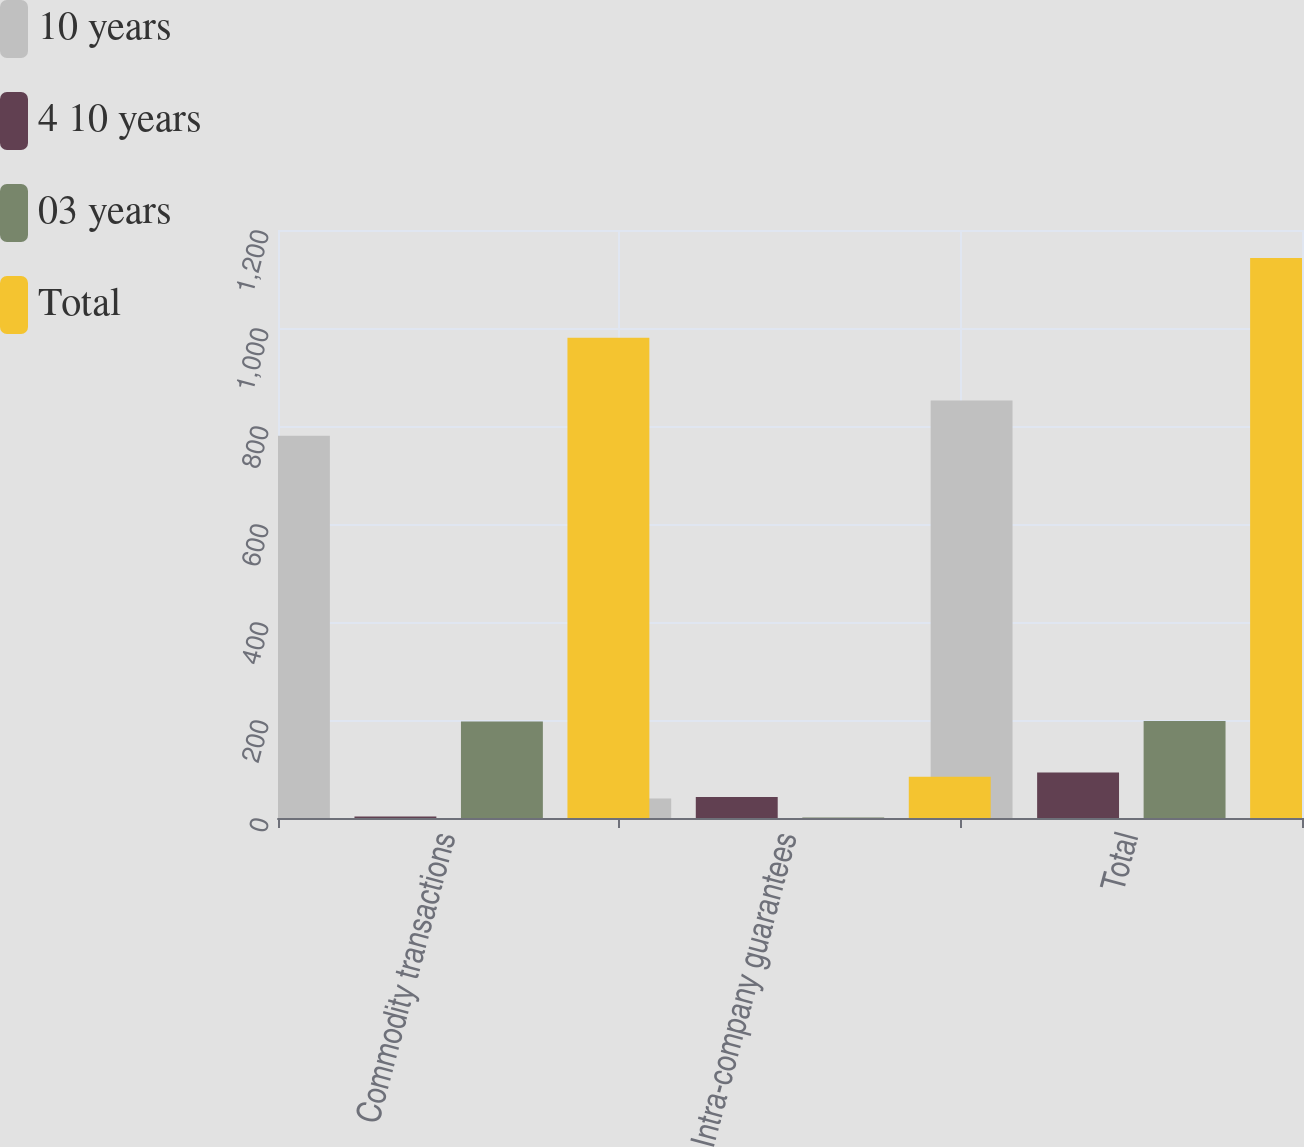Convert chart to OTSL. <chart><loc_0><loc_0><loc_500><loc_500><stacked_bar_chart><ecel><fcel>Commodity transactions<fcel>Intra-company guarantees<fcel>Total<nl><fcel>10 years<fcel>780<fcel>40<fcel>852<nl><fcel>4 10 years<fcel>3<fcel>43<fcel>93<nl><fcel>03 years<fcel>197<fcel>1<fcel>198<nl><fcel>Total<fcel>980<fcel>84<fcel>1143<nl></chart> 